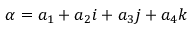<formula> <loc_0><loc_0><loc_500><loc_500>\alpha = a _ { 1 } + a _ { 2 } i + a _ { 3 } j + a _ { 4 } k</formula> 